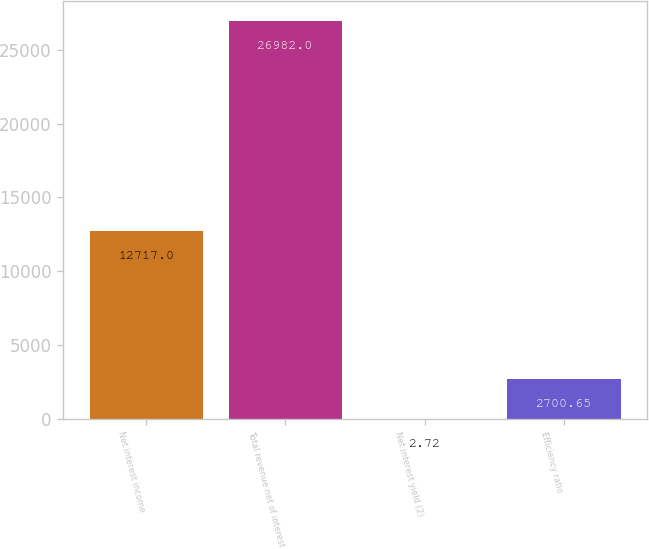Convert chart. <chart><loc_0><loc_0><loc_500><loc_500><bar_chart><fcel>Net interest income<fcel>Total revenue net of interest<fcel>Net interest yield (2)<fcel>Efficiency ratio<nl><fcel>12717<fcel>26982<fcel>2.72<fcel>2700.65<nl></chart> 